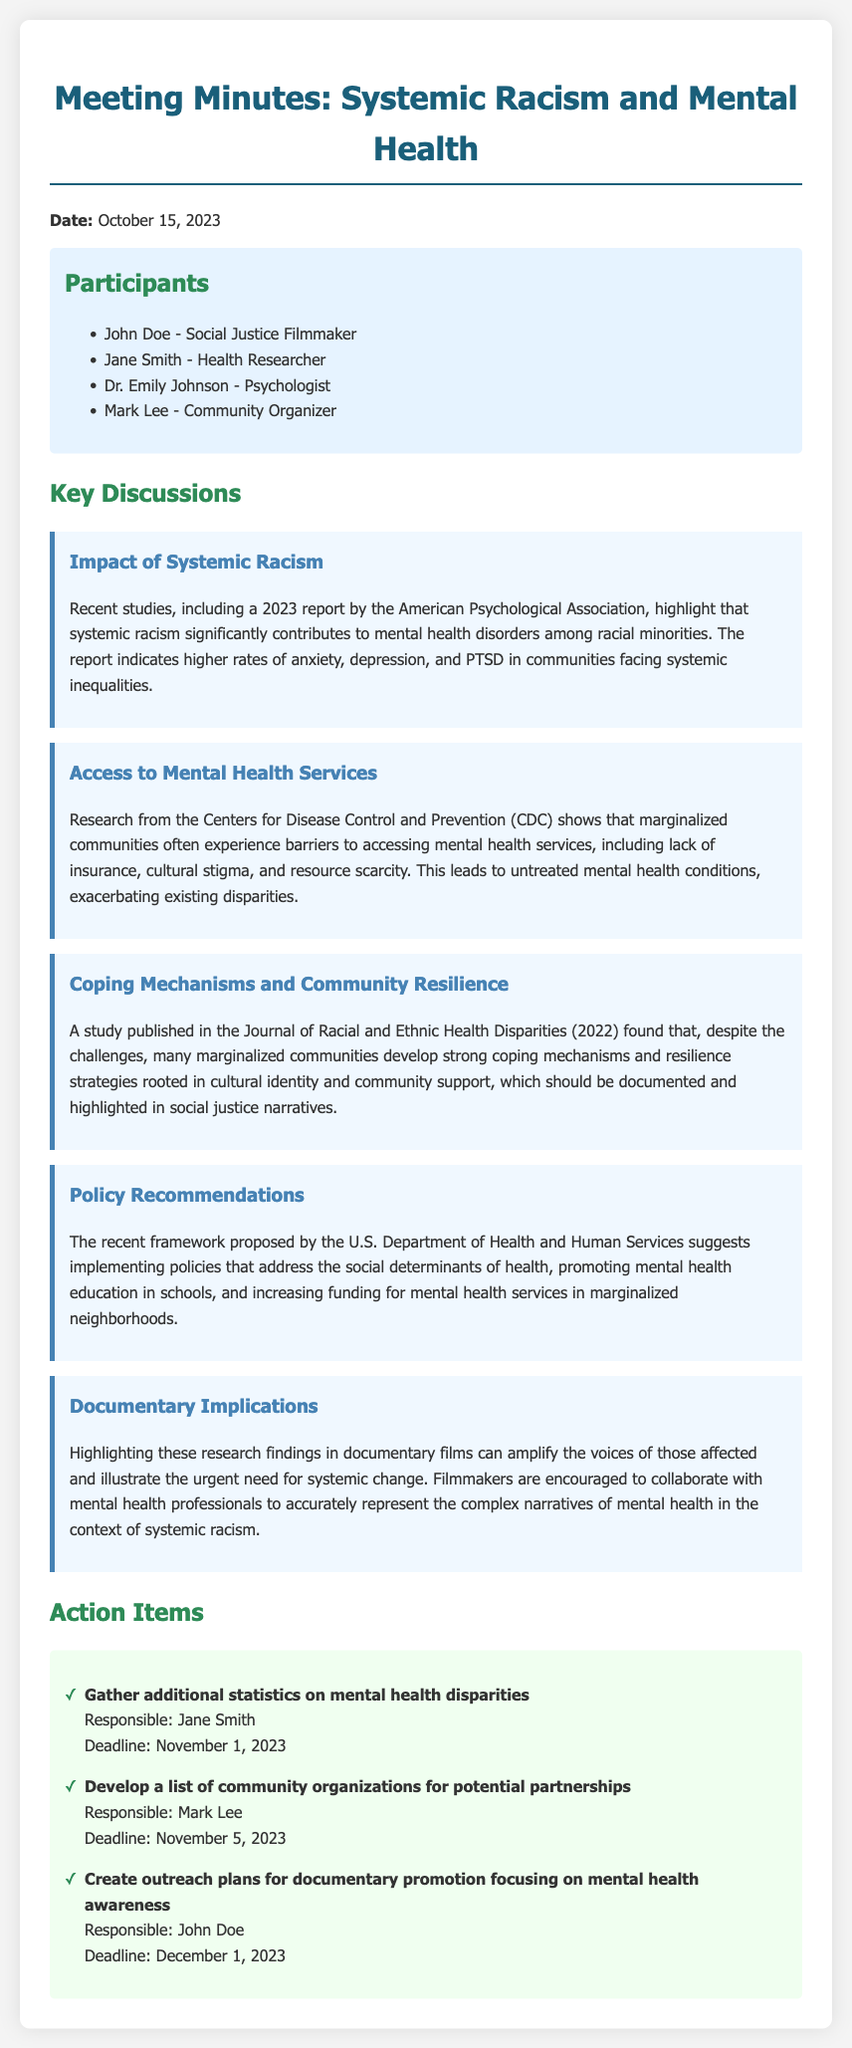what date was the meeting held? The meeting date is explicitly mentioned in the document as October 15, 2023.
Answer: October 15, 2023 who presented the 2023 report on systemic racism? The document indicates that the report was published by the American Psychological Association, but does not specify an individual presenter.
Answer: American Psychological Association what is one barrier to accessing mental health services mentioned? The document outlines several barriers, one of which is cultural stigma.
Answer: cultural stigma which community organizations’ partnerships were proposed? The document mentions developing a list of community organizations for potential partnerships but does not specify any names.
Answer: community organizations what are coping mechanisms rooted in? The findings highlight that coping mechanisms are strongly rooted in cultural identity and community support.
Answer: cultural identity and community support who is responsible for gathering additional statistics? The action items specify that Jane Smith is responsible for this task.
Answer: Jane Smith what is one policy recommendation made by the U.S. Department of Health and Human Services? The document suggests implementing policies that address social determinants of health as a recommendation.
Answer: social determinants of health how many key discussion points are listed? There are five key discussion points highlighted within the document.
Answer: five what type of film narratives are filmmakers encouraged to document? The document encourages filmmakers to capture narratives related to mental health in the context of systemic racism.
Answer: mental health in the context of systemic racism 